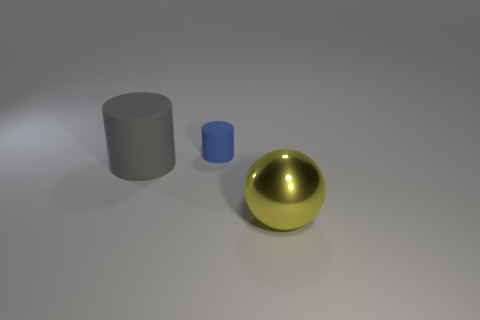Is there any other thing that is the same shape as the tiny rubber object?
Provide a succinct answer. Yes. What number of things are both behind the large gray cylinder and in front of the small cylinder?
Your response must be concise. 0. What material is the tiny blue cylinder?
Ensure brevity in your answer.  Rubber. Are there the same number of big yellow things behind the sphere and big things?
Your answer should be very brief. No. How many large green things are the same shape as the tiny rubber thing?
Provide a succinct answer. 0. Is the shape of the large gray matte thing the same as the big yellow thing?
Your answer should be very brief. No. What number of things are gray rubber things that are in front of the small blue matte cylinder or tiny cylinders?
Give a very brief answer. 2. There is a big object behind the thing right of the tiny blue rubber thing that is on the right side of the big gray rubber cylinder; what is its shape?
Provide a short and direct response. Cylinder. What size is the blue matte thing?
Give a very brief answer. Small. Is the size of the gray rubber cylinder the same as the yellow shiny ball?
Make the answer very short. Yes. 